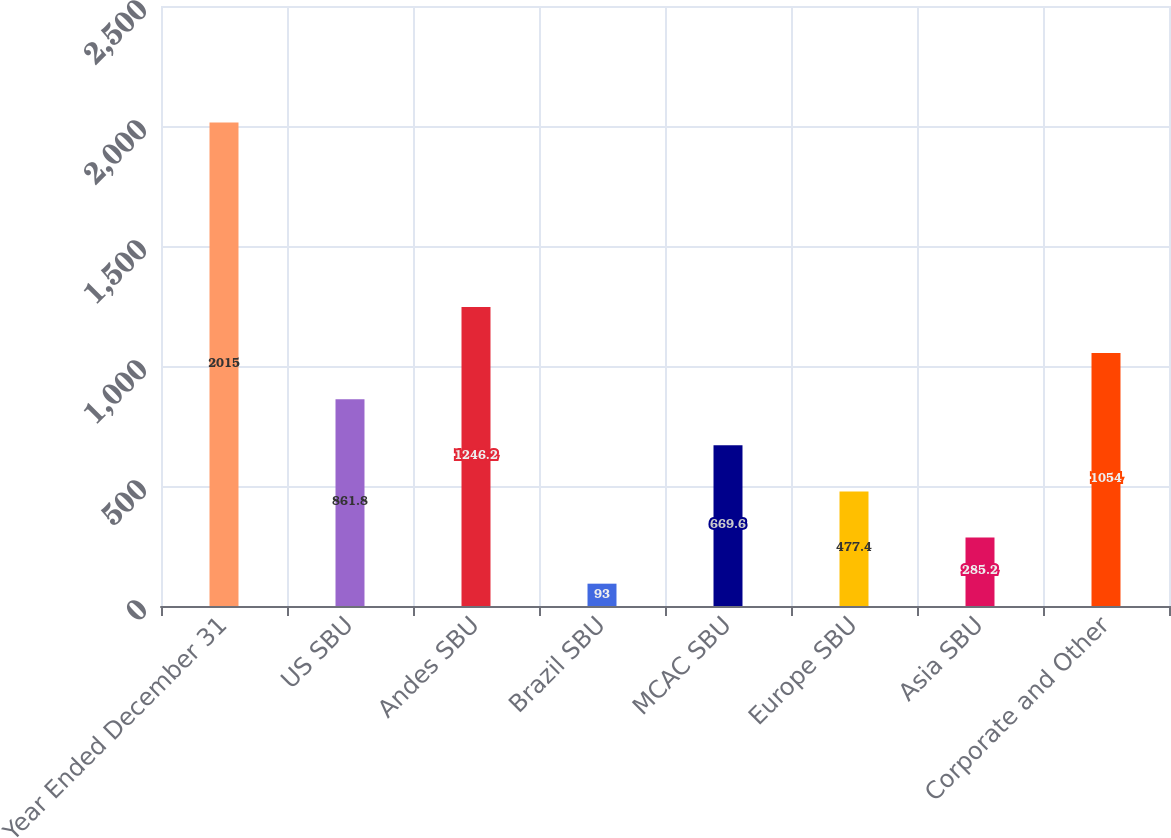Convert chart to OTSL. <chart><loc_0><loc_0><loc_500><loc_500><bar_chart><fcel>Year Ended December 31<fcel>US SBU<fcel>Andes SBU<fcel>Brazil SBU<fcel>MCAC SBU<fcel>Europe SBU<fcel>Asia SBU<fcel>Corporate and Other<nl><fcel>2015<fcel>861.8<fcel>1246.2<fcel>93<fcel>669.6<fcel>477.4<fcel>285.2<fcel>1054<nl></chart> 